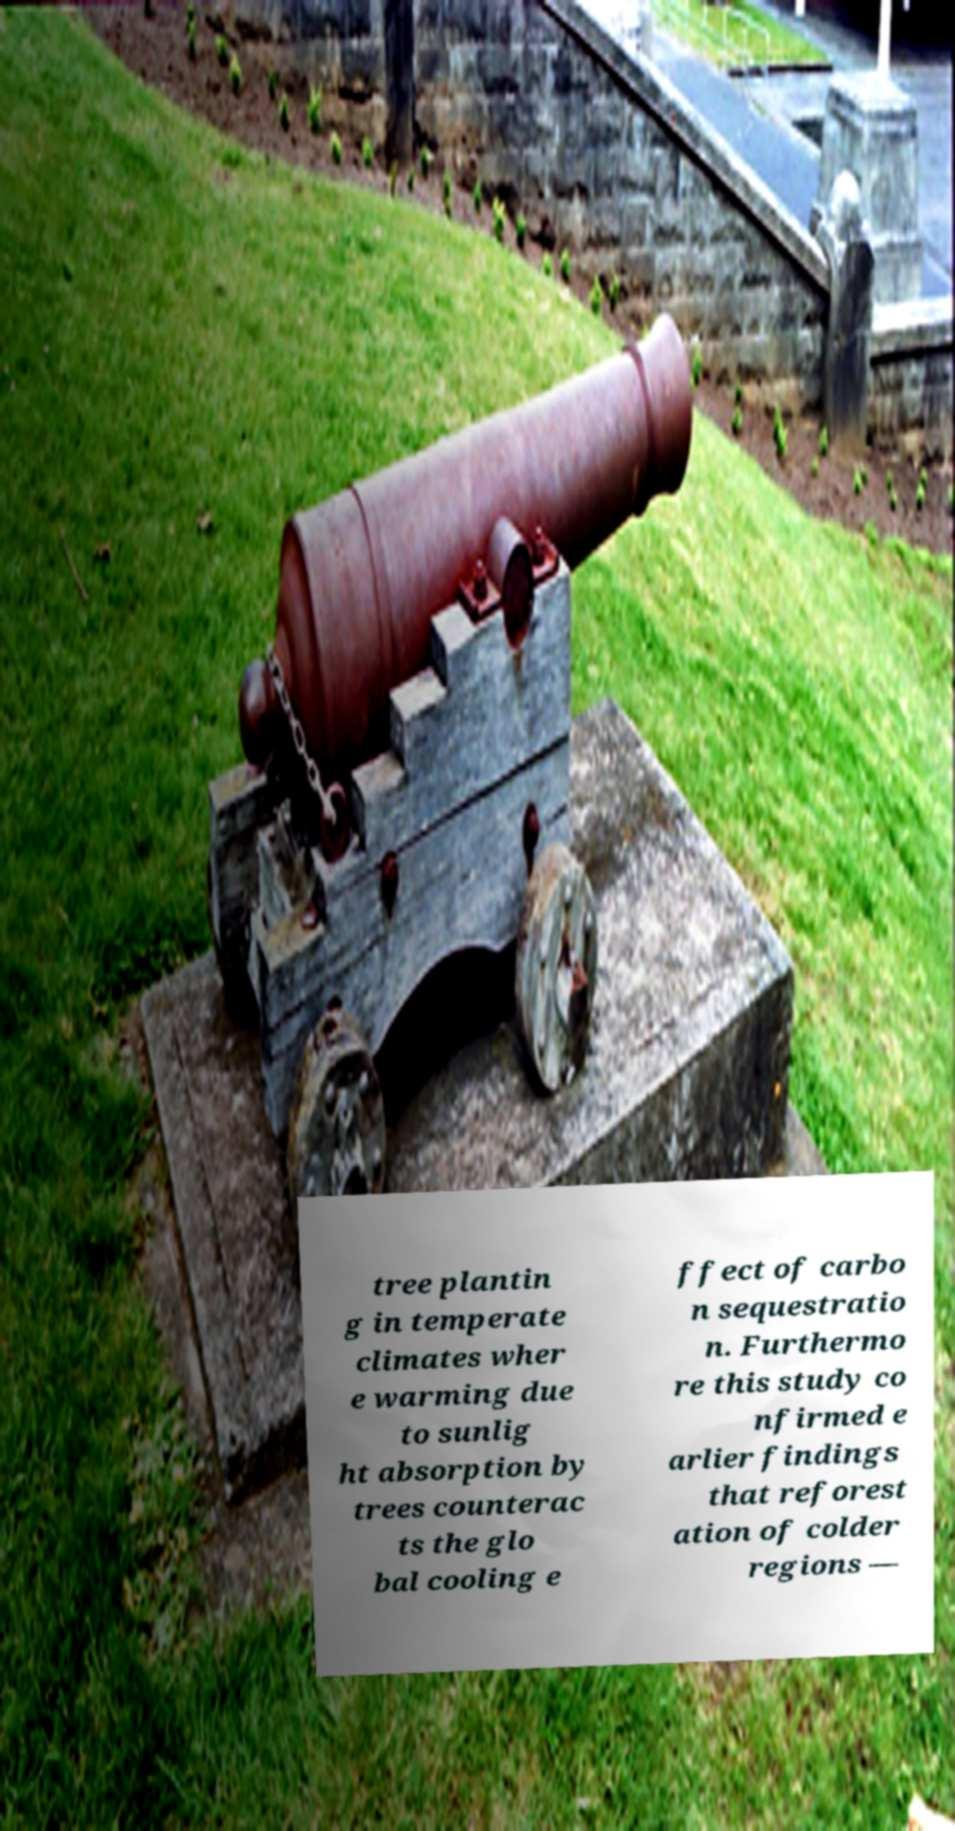I need the written content from this picture converted into text. Can you do that? tree plantin g in temperate climates wher e warming due to sunlig ht absorption by trees counterac ts the glo bal cooling e ffect of carbo n sequestratio n. Furthermo re this study co nfirmed e arlier findings that reforest ation of colder regions — 